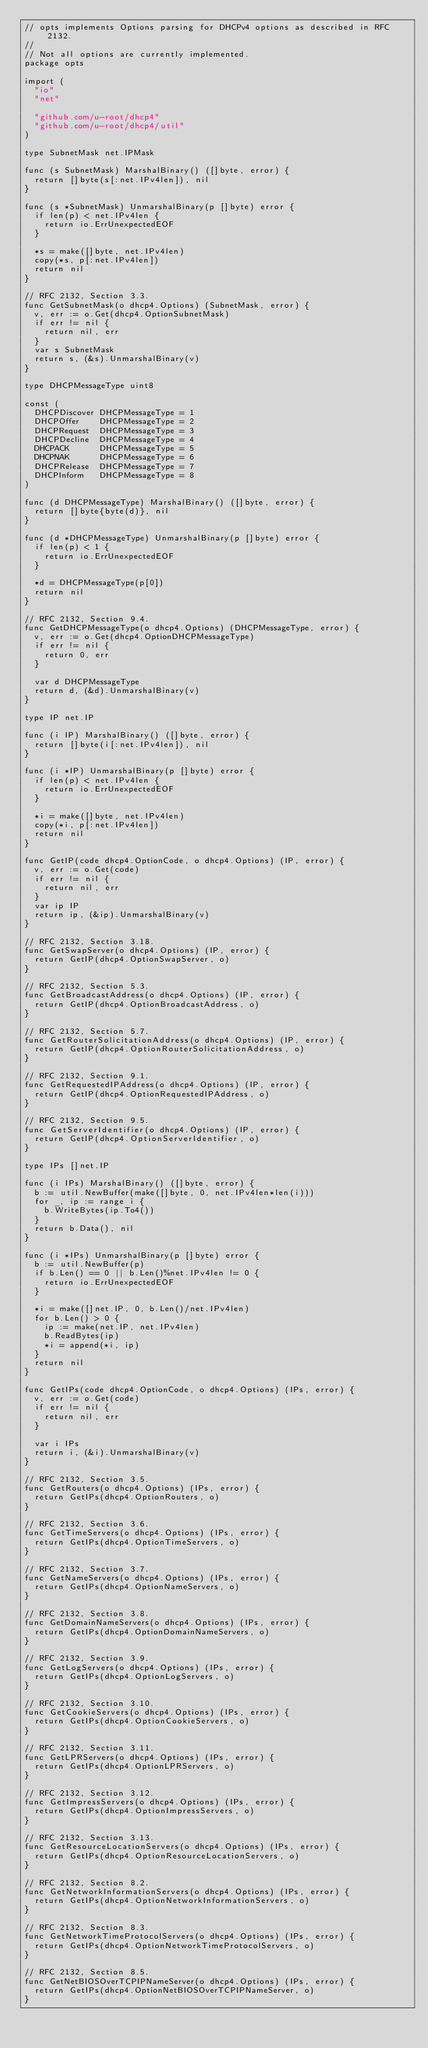Convert code to text. <code><loc_0><loc_0><loc_500><loc_500><_Go_>// opts implements Options parsing for DHCPv4 options as described in RFC 2132.
//
// Not all options are currently implemented.
package opts

import (
	"io"
	"net"

	"github.com/u-root/dhcp4"
	"github.com/u-root/dhcp4/util"
)

type SubnetMask net.IPMask

func (s SubnetMask) MarshalBinary() ([]byte, error) {
	return []byte(s[:net.IPv4len]), nil
}

func (s *SubnetMask) UnmarshalBinary(p []byte) error {
	if len(p) < net.IPv4len {
		return io.ErrUnexpectedEOF
	}

	*s = make([]byte, net.IPv4len)
	copy(*s, p[:net.IPv4len])
	return nil
}

// RFC 2132, Section 3.3.
func GetSubnetMask(o dhcp4.Options) (SubnetMask, error) {
	v, err := o.Get(dhcp4.OptionSubnetMask)
	if err != nil {
		return nil, err
	}
	var s SubnetMask
	return s, (&s).UnmarshalBinary(v)
}

type DHCPMessageType uint8

const (
	DHCPDiscover DHCPMessageType = 1
	DHCPOffer    DHCPMessageType = 2
	DHCPRequest  DHCPMessageType = 3
	DHCPDecline  DHCPMessageType = 4
	DHCPACK      DHCPMessageType = 5
	DHCPNAK      DHCPMessageType = 6
	DHCPRelease  DHCPMessageType = 7
	DHCPInform   DHCPMessageType = 8
)

func (d DHCPMessageType) MarshalBinary() ([]byte, error) {
	return []byte{byte(d)}, nil
}

func (d *DHCPMessageType) UnmarshalBinary(p []byte) error {
	if len(p) < 1 {
		return io.ErrUnexpectedEOF
	}

	*d = DHCPMessageType(p[0])
	return nil
}

// RFC 2132, Section 9.4.
func GetDHCPMessageType(o dhcp4.Options) (DHCPMessageType, error) {
	v, err := o.Get(dhcp4.OptionDHCPMessageType)
	if err != nil {
		return 0, err
	}

	var d DHCPMessageType
	return d, (&d).UnmarshalBinary(v)
}

type IP net.IP

func (i IP) MarshalBinary() ([]byte, error) {
	return []byte(i[:net.IPv4len]), nil
}

func (i *IP) UnmarshalBinary(p []byte) error {
	if len(p) < net.IPv4len {
		return io.ErrUnexpectedEOF
	}

	*i = make([]byte, net.IPv4len)
	copy(*i, p[:net.IPv4len])
	return nil
}

func GetIP(code dhcp4.OptionCode, o dhcp4.Options) (IP, error) {
	v, err := o.Get(code)
	if err != nil {
		return nil, err
	}
	var ip IP
	return ip, (&ip).UnmarshalBinary(v)
}

// RFC 2132, Section 3.18.
func GetSwapServer(o dhcp4.Options) (IP, error) {
	return GetIP(dhcp4.OptionSwapServer, o)
}

// RFC 2132, Section 5.3.
func GetBroadcastAddress(o dhcp4.Options) (IP, error) {
	return GetIP(dhcp4.OptionBroadcastAddress, o)
}

// RFC 2132, Section 5.7.
func GetRouterSolicitationAddress(o dhcp4.Options) (IP, error) {
	return GetIP(dhcp4.OptionRouterSolicitationAddress, o)
}

// RFC 2132, Section 9.1.
func GetRequestedIPAddress(o dhcp4.Options) (IP, error) {
	return GetIP(dhcp4.OptionRequestedIPAddress, o)
}

// RFC 2132, Section 9.5.
func GetServerIdentifier(o dhcp4.Options) (IP, error) {
	return GetIP(dhcp4.OptionServerIdentifier, o)
}

type IPs []net.IP

func (i IPs) MarshalBinary() ([]byte, error) {
	b := util.NewBuffer(make([]byte, 0, net.IPv4len*len(i)))
	for _, ip := range i {
		b.WriteBytes(ip.To4())
	}
	return b.Data(), nil
}

func (i *IPs) UnmarshalBinary(p []byte) error {
	b := util.NewBuffer(p)
	if b.Len() == 0 || b.Len()%net.IPv4len != 0 {
		return io.ErrUnexpectedEOF
	}

	*i = make([]net.IP, 0, b.Len()/net.IPv4len)
	for b.Len() > 0 {
		ip := make(net.IP, net.IPv4len)
		b.ReadBytes(ip)
		*i = append(*i, ip)
	}
	return nil
}

func GetIPs(code dhcp4.OptionCode, o dhcp4.Options) (IPs, error) {
	v, err := o.Get(code)
	if err != nil {
		return nil, err
	}

	var i IPs
	return i, (&i).UnmarshalBinary(v)
}

// RFC 2132, Section 3.5.
func GetRouters(o dhcp4.Options) (IPs, error) {
	return GetIPs(dhcp4.OptionRouters, o)
}

// RFC 2132, Section 3.6.
func GetTimeServers(o dhcp4.Options) (IPs, error) {
	return GetIPs(dhcp4.OptionTimeServers, o)
}

// RFC 2132, Section 3.7.
func GetNameServers(o dhcp4.Options) (IPs, error) {
	return GetIPs(dhcp4.OptionNameServers, o)
}

// RFC 2132, Section 3.8.
func GetDomainNameServers(o dhcp4.Options) (IPs, error) {
	return GetIPs(dhcp4.OptionDomainNameServers, o)
}

// RFC 2132, Section 3.9.
func GetLogServers(o dhcp4.Options) (IPs, error) {
	return GetIPs(dhcp4.OptionLogServers, o)
}

// RFC 2132, Section 3.10.
func GetCookieServers(o dhcp4.Options) (IPs, error) {
	return GetIPs(dhcp4.OptionCookieServers, o)
}

// RFC 2132, Section 3.11.
func GetLPRServers(o dhcp4.Options) (IPs, error) {
	return GetIPs(dhcp4.OptionLPRServers, o)
}

// RFC 2132, Section 3.12.
func GetImpressServers(o dhcp4.Options) (IPs, error) {
	return GetIPs(dhcp4.OptionImpressServers, o)
}

// RFC 2132, Section 3.13.
func GetResourceLocationServers(o dhcp4.Options) (IPs, error) {
	return GetIPs(dhcp4.OptionResourceLocationServers, o)
}

// RFC 2132, Section 8.2.
func GetNetworkInformationServers(o dhcp4.Options) (IPs, error) {
	return GetIPs(dhcp4.OptionNetworkInformationServers, o)
}

// RFC 2132, Section 8.3.
func GetNetworkTimeProtocolServers(o dhcp4.Options) (IPs, error) {
	return GetIPs(dhcp4.OptionNetworkTimeProtocolServers, o)
}

// RFC 2132, Section 8.5.
func GetNetBIOSOverTCPIPNameServer(o dhcp4.Options) (IPs, error) {
	return GetIPs(dhcp4.OptionNetBIOSOverTCPIPNameServer, o)
}
</code> 